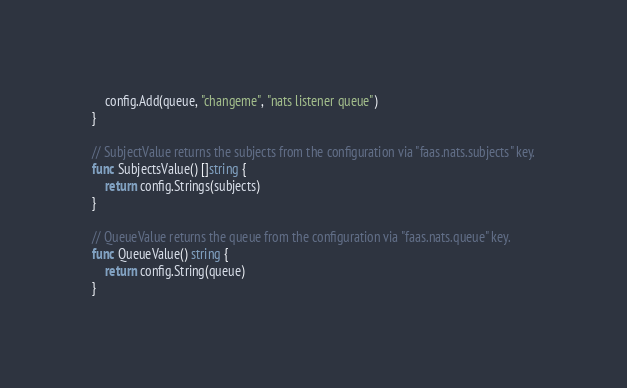<code> <loc_0><loc_0><loc_500><loc_500><_Go_>	config.Add(queue, "changeme", "nats listener queue")
}

// SubjectValue returns the subjects from the configuration via "faas.nats.subjects" key.
func SubjectsValue() []string {
	return config.Strings(subjects)
}

// QueueValue returns the queue from the configuration via "faas.nats.queue" key.
func QueueValue() string {
	return config.String(queue)
}
</code> 